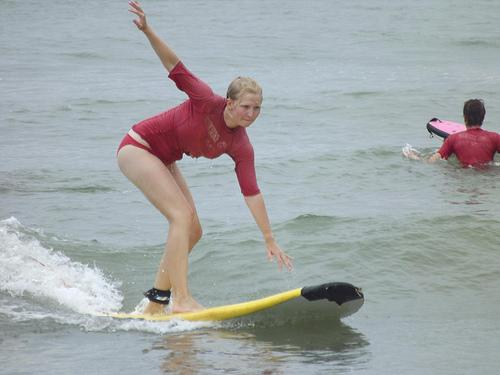Question: what color is the woman's hair?
Choices:
A. Brown.
B. Yellow.
C. Red.
D. Blonde.
Answer with the letter. Answer: D Question: what color is the man's hair?
Choices:
A. Black.
B. Red.
C. Blonde.
D. Brown.
Answer with the letter. Answer: D Question: where are the people?
Choices:
A. In the ocean.
B. The lake.
C. The pool.
D. The pond.
Answer with the letter. Answer: A Question: what color is the man's surfboard?
Choices:
A. Pink.
B. Blue.
C. Red.
D. Yellow.
Answer with the letter. Answer: A Question: what are the people doing?
Choices:
A. Surfing.
B. Sewing.
C. Singing.
D. Swimming.
Answer with the letter. Answer: A Question: what color are the people's outfits?
Choices:
A. Purple.
B. Green.
C. Yellow.
D. Red.
Answer with the letter. Answer: D 